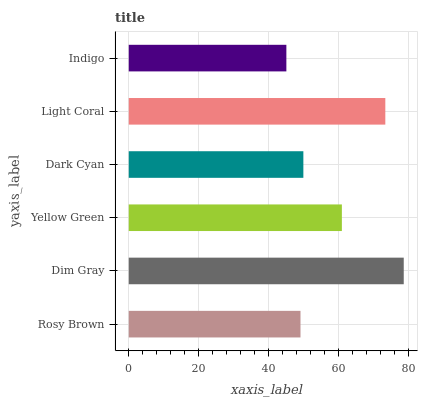Is Indigo the minimum?
Answer yes or no. Yes. Is Dim Gray the maximum?
Answer yes or no. Yes. Is Yellow Green the minimum?
Answer yes or no. No. Is Yellow Green the maximum?
Answer yes or no. No. Is Dim Gray greater than Yellow Green?
Answer yes or no. Yes. Is Yellow Green less than Dim Gray?
Answer yes or no. Yes. Is Yellow Green greater than Dim Gray?
Answer yes or no. No. Is Dim Gray less than Yellow Green?
Answer yes or no. No. Is Yellow Green the high median?
Answer yes or no. Yes. Is Dark Cyan the low median?
Answer yes or no. Yes. Is Light Coral the high median?
Answer yes or no. No. Is Rosy Brown the low median?
Answer yes or no. No. 